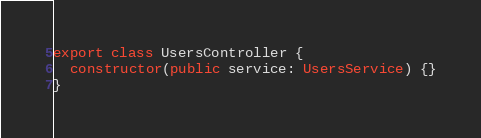<code> <loc_0><loc_0><loc_500><loc_500><_TypeScript_>export class UsersController {
  constructor(public service: UsersService) {}
}
</code> 